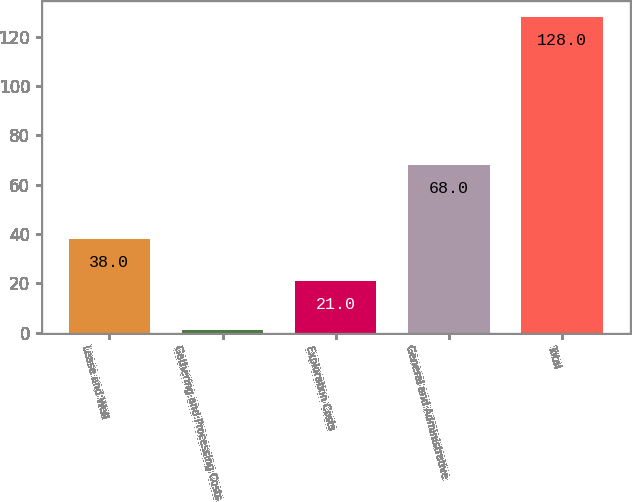Convert chart. <chart><loc_0><loc_0><loc_500><loc_500><bar_chart><fcel>Lease and Well<fcel>Gathering and Processing Costs<fcel>Exploration Costs<fcel>General and Administrative<fcel>Total<nl><fcel>38<fcel>1<fcel>21<fcel>68<fcel>128<nl></chart> 